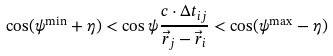<formula> <loc_0><loc_0><loc_500><loc_500>\cos ( \psi ^ { \min } + \eta ) < \cos \psi \frac { c \cdot \Delta t _ { i j } } { \vec { r } _ { j } - \vec { r } _ { i } } < \cos ( { \psi ^ { \max } - \eta } )</formula> 